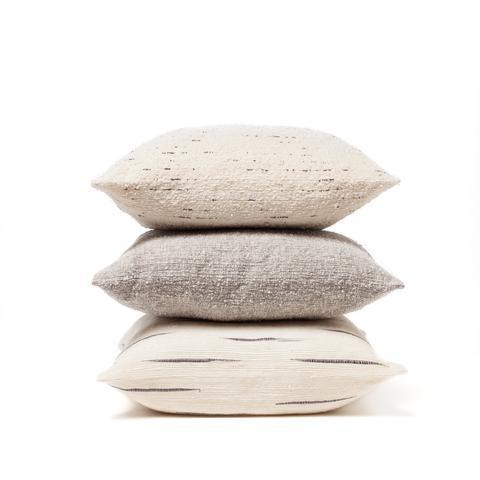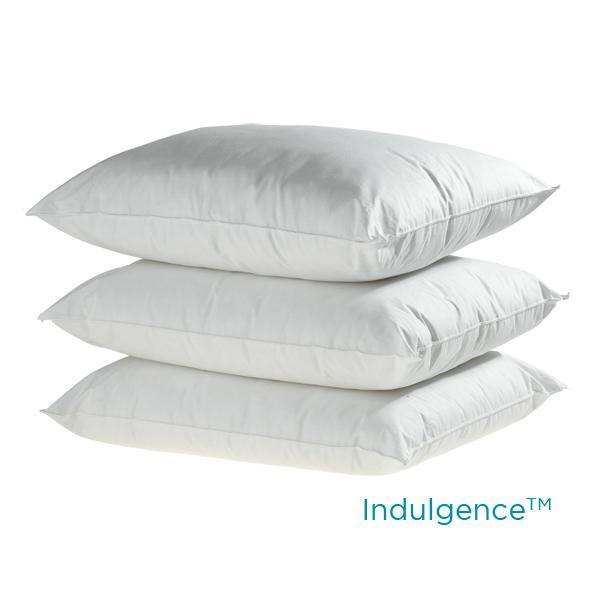The first image is the image on the left, the second image is the image on the right. For the images shown, is this caption "The left image contains a stack of four pillows and the right image contains a stack of two pillows." true? Answer yes or no. No. The first image is the image on the left, the second image is the image on the right. For the images displayed, is the sentence "The right image contains two  white pillows stacked vertically on top of each other." factually correct? Answer yes or no. No. 